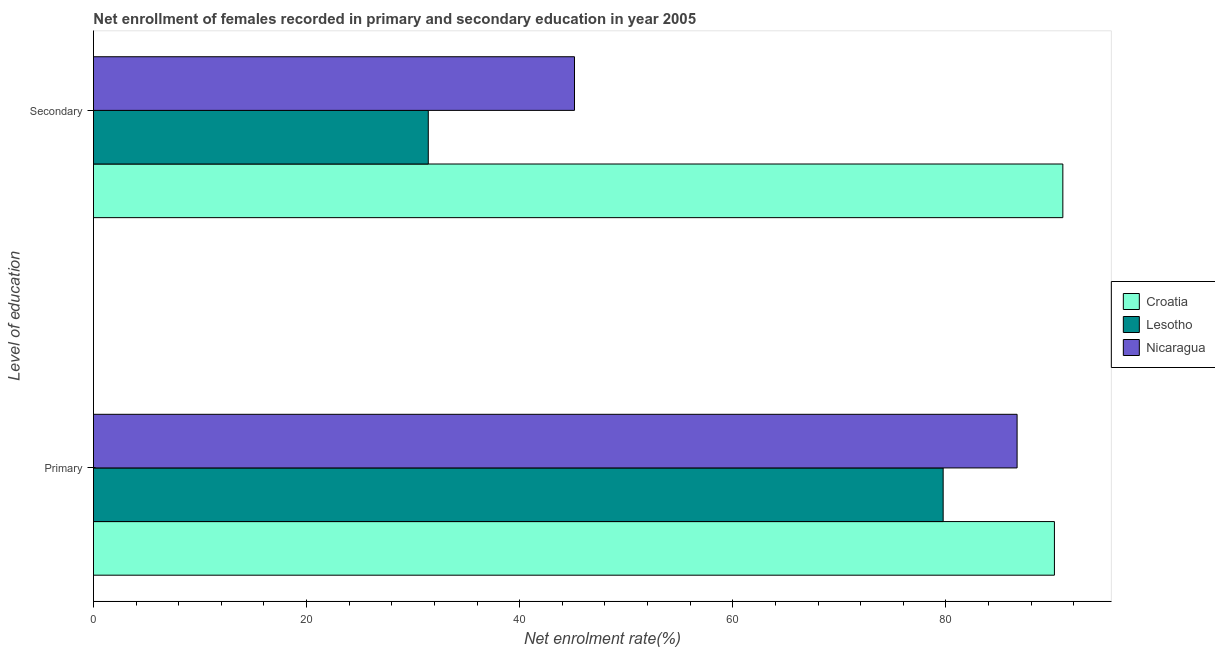Are the number of bars per tick equal to the number of legend labels?
Offer a terse response. Yes. What is the label of the 2nd group of bars from the top?
Give a very brief answer. Primary. What is the enrollment rate in primary education in Croatia?
Offer a very short reply. 90.18. Across all countries, what is the maximum enrollment rate in secondary education?
Provide a short and direct response. 90.97. Across all countries, what is the minimum enrollment rate in secondary education?
Your answer should be very brief. 31.42. In which country was the enrollment rate in primary education maximum?
Your answer should be very brief. Croatia. In which country was the enrollment rate in primary education minimum?
Offer a very short reply. Lesotho. What is the total enrollment rate in primary education in the graph?
Your response must be concise. 256.59. What is the difference between the enrollment rate in secondary education in Nicaragua and that in Lesotho?
Give a very brief answer. 13.72. What is the difference between the enrollment rate in secondary education in Nicaragua and the enrollment rate in primary education in Lesotho?
Ensure brevity in your answer.  -34.6. What is the average enrollment rate in secondary education per country?
Your response must be concise. 55.84. What is the difference between the enrollment rate in primary education and enrollment rate in secondary education in Croatia?
Provide a succinct answer. -0.79. What is the ratio of the enrollment rate in secondary education in Croatia to that in Nicaragua?
Offer a terse response. 2.02. In how many countries, is the enrollment rate in secondary education greater than the average enrollment rate in secondary education taken over all countries?
Your answer should be compact. 1. What does the 2nd bar from the top in Primary represents?
Provide a succinct answer. Lesotho. What does the 2nd bar from the bottom in Primary represents?
Your answer should be compact. Lesotho. How many bars are there?
Keep it short and to the point. 6. Are all the bars in the graph horizontal?
Offer a very short reply. Yes. How many countries are there in the graph?
Your response must be concise. 3. What is the title of the graph?
Make the answer very short. Net enrollment of females recorded in primary and secondary education in year 2005. Does "East Asia (developing only)" appear as one of the legend labels in the graph?
Offer a very short reply. No. What is the label or title of the X-axis?
Your answer should be compact. Net enrolment rate(%). What is the label or title of the Y-axis?
Ensure brevity in your answer.  Level of education. What is the Net enrolment rate(%) in Croatia in Primary?
Your answer should be compact. 90.18. What is the Net enrolment rate(%) in Lesotho in Primary?
Provide a succinct answer. 79.74. What is the Net enrolment rate(%) of Nicaragua in Primary?
Provide a short and direct response. 86.67. What is the Net enrolment rate(%) in Croatia in Secondary?
Give a very brief answer. 90.97. What is the Net enrolment rate(%) of Lesotho in Secondary?
Your answer should be compact. 31.42. What is the Net enrolment rate(%) in Nicaragua in Secondary?
Your response must be concise. 45.14. Across all Level of education, what is the maximum Net enrolment rate(%) of Croatia?
Provide a short and direct response. 90.97. Across all Level of education, what is the maximum Net enrolment rate(%) in Lesotho?
Provide a short and direct response. 79.74. Across all Level of education, what is the maximum Net enrolment rate(%) of Nicaragua?
Offer a very short reply. 86.67. Across all Level of education, what is the minimum Net enrolment rate(%) of Croatia?
Give a very brief answer. 90.18. Across all Level of education, what is the minimum Net enrolment rate(%) of Lesotho?
Your response must be concise. 31.42. Across all Level of education, what is the minimum Net enrolment rate(%) in Nicaragua?
Your answer should be compact. 45.14. What is the total Net enrolment rate(%) in Croatia in the graph?
Your answer should be very brief. 181.15. What is the total Net enrolment rate(%) in Lesotho in the graph?
Your response must be concise. 111.15. What is the total Net enrolment rate(%) of Nicaragua in the graph?
Provide a short and direct response. 131.81. What is the difference between the Net enrolment rate(%) in Croatia in Primary and that in Secondary?
Provide a succinct answer. -0.79. What is the difference between the Net enrolment rate(%) in Lesotho in Primary and that in Secondary?
Ensure brevity in your answer.  48.32. What is the difference between the Net enrolment rate(%) in Nicaragua in Primary and that in Secondary?
Give a very brief answer. 41.54. What is the difference between the Net enrolment rate(%) in Croatia in Primary and the Net enrolment rate(%) in Lesotho in Secondary?
Your answer should be very brief. 58.76. What is the difference between the Net enrolment rate(%) of Croatia in Primary and the Net enrolment rate(%) of Nicaragua in Secondary?
Make the answer very short. 45.04. What is the difference between the Net enrolment rate(%) in Lesotho in Primary and the Net enrolment rate(%) in Nicaragua in Secondary?
Your answer should be very brief. 34.6. What is the average Net enrolment rate(%) in Croatia per Level of education?
Offer a very short reply. 90.57. What is the average Net enrolment rate(%) in Lesotho per Level of education?
Ensure brevity in your answer.  55.58. What is the average Net enrolment rate(%) of Nicaragua per Level of education?
Offer a very short reply. 65.91. What is the difference between the Net enrolment rate(%) of Croatia and Net enrolment rate(%) of Lesotho in Primary?
Provide a succinct answer. 10.44. What is the difference between the Net enrolment rate(%) of Croatia and Net enrolment rate(%) of Nicaragua in Primary?
Ensure brevity in your answer.  3.5. What is the difference between the Net enrolment rate(%) in Lesotho and Net enrolment rate(%) in Nicaragua in Primary?
Your answer should be very brief. -6.94. What is the difference between the Net enrolment rate(%) of Croatia and Net enrolment rate(%) of Lesotho in Secondary?
Keep it short and to the point. 59.55. What is the difference between the Net enrolment rate(%) of Croatia and Net enrolment rate(%) of Nicaragua in Secondary?
Keep it short and to the point. 45.83. What is the difference between the Net enrolment rate(%) in Lesotho and Net enrolment rate(%) in Nicaragua in Secondary?
Your answer should be compact. -13.72. What is the ratio of the Net enrolment rate(%) in Lesotho in Primary to that in Secondary?
Keep it short and to the point. 2.54. What is the ratio of the Net enrolment rate(%) of Nicaragua in Primary to that in Secondary?
Your answer should be compact. 1.92. What is the difference between the highest and the second highest Net enrolment rate(%) in Croatia?
Ensure brevity in your answer.  0.79. What is the difference between the highest and the second highest Net enrolment rate(%) in Lesotho?
Make the answer very short. 48.32. What is the difference between the highest and the second highest Net enrolment rate(%) in Nicaragua?
Provide a short and direct response. 41.54. What is the difference between the highest and the lowest Net enrolment rate(%) in Croatia?
Ensure brevity in your answer.  0.79. What is the difference between the highest and the lowest Net enrolment rate(%) of Lesotho?
Make the answer very short. 48.32. What is the difference between the highest and the lowest Net enrolment rate(%) in Nicaragua?
Provide a short and direct response. 41.54. 